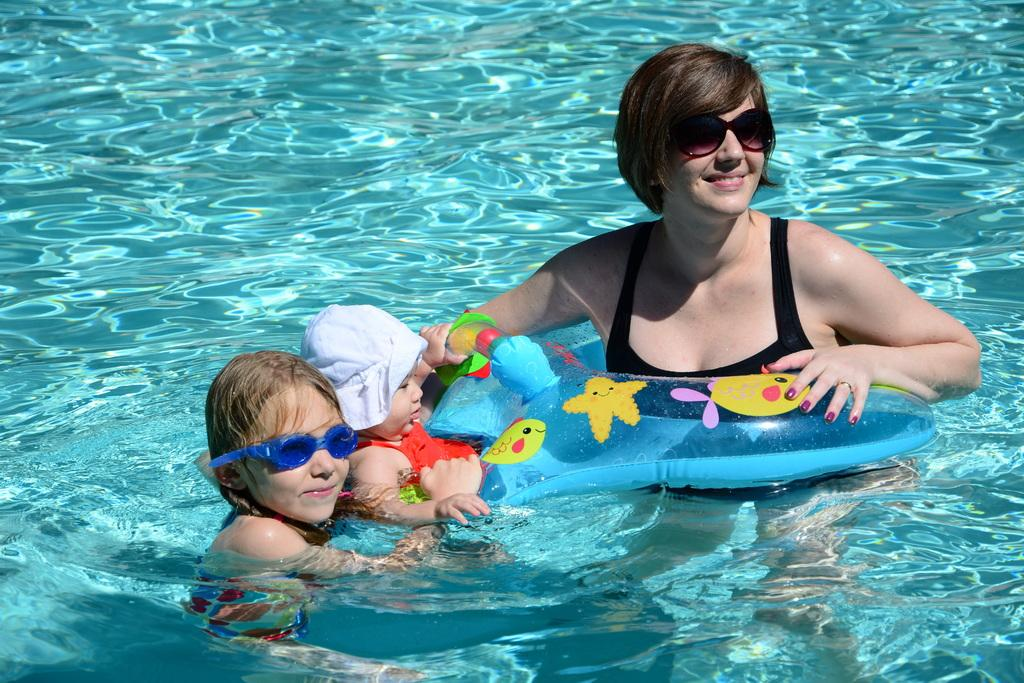What is the main feature in the image? There is a pool in the image. Who or what is in the pool? There is a woman and two children in the pool. How is the woman feeling in the image? The woman is smiling. How many frogs are in the pool with the woman and children? There are no frogs present in the image. What type of care is the woman providing for the children in the pool? The image does not show any specific care being provided by the woman to the children. 